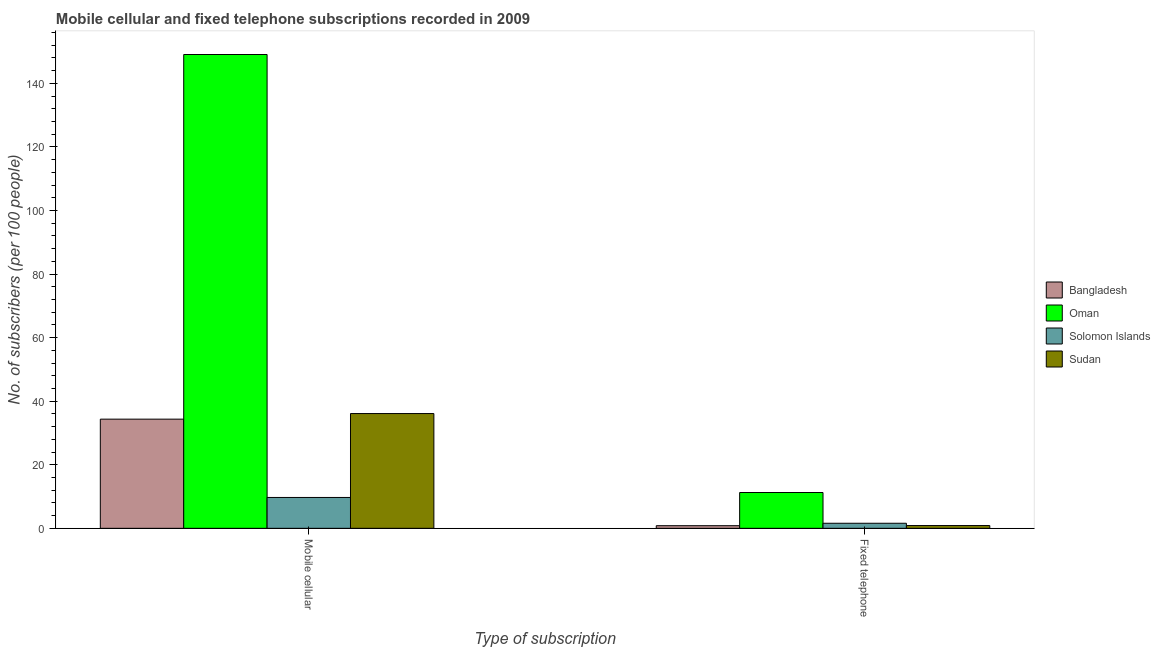Are the number of bars on each tick of the X-axis equal?
Offer a very short reply. Yes. How many bars are there on the 2nd tick from the left?
Give a very brief answer. 4. How many bars are there on the 1st tick from the right?
Offer a very short reply. 4. What is the label of the 1st group of bars from the left?
Provide a succinct answer. Mobile cellular. What is the number of fixed telephone subscribers in Solomon Islands?
Your answer should be very brief. 1.59. Across all countries, what is the maximum number of mobile cellular subscribers?
Keep it short and to the point. 149.09. Across all countries, what is the minimum number of fixed telephone subscribers?
Offer a terse response. 0.83. In which country was the number of mobile cellular subscribers maximum?
Ensure brevity in your answer.  Oman. What is the total number of fixed telephone subscribers in the graph?
Keep it short and to the point. 14.56. What is the difference between the number of fixed telephone subscribers in Oman and that in Solomon Islands?
Your answer should be very brief. 9.68. What is the difference between the number of fixed telephone subscribers in Oman and the number of mobile cellular subscribers in Bangladesh?
Your response must be concise. -23.08. What is the average number of mobile cellular subscribers per country?
Ensure brevity in your answer.  57.32. What is the difference between the number of fixed telephone subscribers and number of mobile cellular subscribers in Sudan?
Make the answer very short. -35.24. In how many countries, is the number of fixed telephone subscribers greater than 136 ?
Your answer should be compact. 0. What is the ratio of the number of mobile cellular subscribers in Sudan to that in Solomon Islands?
Provide a succinct answer. 3.72. Is the number of mobile cellular subscribers in Solomon Islands less than that in Oman?
Provide a short and direct response. Yes. In how many countries, is the number of mobile cellular subscribers greater than the average number of mobile cellular subscribers taken over all countries?
Your answer should be very brief. 1. What does the 4th bar from the left in Fixed telephone represents?
Your answer should be very brief. Sudan. What does the 1st bar from the right in Fixed telephone represents?
Your answer should be very brief. Sudan. Are all the bars in the graph horizontal?
Give a very brief answer. No. What is the difference between two consecutive major ticks on the Y-axis?
Give a very brief answer. 20. Does the graph contain any zero values?
Make the answer very short. No. Does the graph contain grids?
Offer a terse response. No. What is the title of the graph?
Offer a terse response. Mobile cellular and fixed telephone subscriptions recorded in 2009. Does "Mali" appear as one of the legend labels in the graph?
Your answer should be compact. No. What is the label or title of the X-axis?
Offer a very short reply. Type of subscription. What is the label or title of the Y-axis?
Your response must be concise. No. of subscribers (per 100 people). What is the No. of subscribers (per 100 people) of Bangladesh in Mobile cellular?
Provide a short and direct response. 34.35. What is the No. of subscribers (per 100 people) of Oman in Mobile cellular?
Provide a short and direct response. 149.09. What is the No. of subscribers (per 100 people) in Solomon Islands in Mobile cellular?
Give a very brief answer. 9.71. What is the No. of subscribers (per 100 people) of Sudan in Mobile cellular?
Provide a succinct answer. 36.11. What is the No. of subscribers (per 100 people) in Bangladesh in Fixed telephone?
Your answer should be very brief. 0.83. What is the No. of subscribers (per 100 people) of Oman in Fixed telephone?
Give a very brief answer. 11.27. What is the No. of subscribers (per 100 people) in Solomon Islands in Fixed telephone?
Your answer should be very brief. 1.59. What is the No. of subscribers (per 100 people) in Sudan in Fixed telephone?
Give a very brief answer. 0.87. Across all Type of subscription, what is the maximum No. of subscribers (per 100 people) of Bangladesh?
Your response must be concise. 34.35. Across all Type of subscription, what is the maximum No. of subscribers (per 100 people) in Oman?
Give a very brief answer. 149.09. Across all Type of subscription, what is the maximum No. of subscribers (per 100 people) in Solomon Islands?
Keep it short and to the point. 9.71. Across all Type of subscription, what is the maximum No. of subscribers (per 100 people) of Sudan?
Offer a very short reply. 36.11. Across all Type of subscription, what is the minimum No. of subscribers (per 100 people) in Bangladesh?
Keep it short and to the point. 0.83. Across all Type of subscription, what is the minimum No. of subscribers (per 100 people) in Oman?
Your answer should be very brief. 11.27. Across all Type of subscription, what is the minimum No. of subscribers (per 100 people) of Solomon Islands?
Your response must be concise. 1.59. Across all Type of subscription, what is the minimum No. of subscribers (per 100 people) in Sudan?
Your answer should be compact. 0.87. What is the total No. of subscribers (per 100 people) in Bangladesh in the graph?
Keep it short and to the point. 35.18. What is the total No. of subscribers (per 100 people) of Oman in the graph?
Keep it short and to the point. 160.36. What is the total No. of subscribers (per 100 people) in Solomon Islands in the graph?
Your answer should be compact. 11.3. What is the total No. of subscribers (per 100 people) of Sudan in the graph?
Your response must be concise. 36.98. What is the difference between the No. of subscribers (per 100 people) in Bangladesh in Mobile cellular and that in Fixed telephone?
Your response must be concise. 33.53. What is the difference between the No. of subscribers (per 100 people) in Oman in Mobile cellular and that in Fixed telephone?
Your answer should be very brief. 137.82. What is the difference between the No. of subscribers (per 100 people) in Solomon Islands in Mobile cellular and that in Fixed telephone?
Your answer should be very brief. 8.12. What is the difference between the No. of subscribers (per 100 people) of Sudan in Mobile cellular and that in Fixed telephone?
Keep it short and to the point. 35.24. What is the difference between the No. of subscribers (per 100 people) in Bangladesh in Mobile cellular and the No. of subscribers (per 100 people) in Oman in Fixed telephone?
Your answer should be compact. 23.08. What is the difference between the No. of subscribers (per 100 people) of Bangladesh in Mobile cellular and the No. of subscribers (per 100 people) of Solomon Islands in Fixed telephone?
Your response must be concise. 32.76. What is the difference between the No. of subscribers (per 100 people) in Bangladesh in Mobile cellular and the No. of subscribers (per 100 people) in Sudan in Fixed telephone?
Make the answer very short. 33.48. What is the difference between the No. of subscribers (per 100 people) of Oman in Mobile cellular and the No. of subscribers (per 100 people) of Solomon Islands in Fixed telephone?
Offer a terse response. 147.5. What is the difference between the No. of subscribers (per 100 people) in Oman in Mobile cellular and the No. of subscribers (per 100 people) in Sudan in Fixed telephone?
Your answer should be compact. 148.22. What is the difference between the No. of subscribers (per 100 people) in Solomon Islands in Mobile cellular and the No. of subscribers (per 100 people) in Sudan in Fixed telephone?
Provide a short and direct response. 8.84. What is the average No. of subscribers (per 100 people) of Bangladesh per Type of subscription?
Provide a short and direct response. 17.59. What is the average No. of subscribers (per 100 people) in Oman per Type of subscription?
Make the answer very short. 80.18. What is the average No. of subscribers (per 100 people) of Solomon Islands per Type of subscription?
Offer a very short reply. 5.65. What is the average No. of subscribers (per 100 people) of Sudan per Type of subscription?
Make the answer very short. 18.49. What is the difference between the No. of subscribers (per 100 people) of Bangladesh and No. of subscribers (per 100 people) of Oman in Mobile cellular?
Make the answer very short. -114.74. What is the difference between the No. of subscribers (per 100 people) in Bangladesh and No. of subscribers (per 100 people) in Solomon Islands in Mobile cellular?
Ensure brevity in your answer.  24.64. What is the difference between the No. of subscribers (per 100 people) in Bangladesh and No. of subscribers (per 100 people) in Sudan in Mobile cellular?
Keep it short and to the point. -1.76. What is the difference between the No. of subscribers (per 100 people) in Oman and No. of subscribers (per 100 people) in Solomon Islands in Mobile cellular?
Provide a short and direct response. 139.38. What is the difference between the No. of subscribers (per 100 people) in Oman and No. of subscribers (per 100 people) in Sudan in Mobile cellular?
Provide a succinct answer. 112.98. What is the difference between the No. of subscribers (per 100 people) in Solomon Islands and No. of subscribers (per 100 people) in Sudan in Mobile cellular?
Provide a short and direct response. -26.4. What is the difference between the No. of subscribers (per 100 people) of Bangladesh and No. of subscribers (per 100 people) of Oman in Fixed telephone?
Provide a succinct answer. -10.44. What is the difference between the No. of subscribers (per 100 people) of Bangladesh and No. of subscribers (per 100 people) of Solomon Islands in Fixed telephone?
Give a very brief answer. -0.77. What is the difference between the No. of subscribers (per 100 people) in Bangladesh and No. of subscribers (per 100 people) in Sudan in Fixed telephone?
Ensure brevity in your answer.  -0.05. What is the difference between the No. of subscribers (per 100 people) in Oman and No. of subscribers (per 100 people) in Solomon Islands in Fixed telephone?
Offer a very short reply. 9.68. What is the difference between the No. of subscribers (per 100 people) in Oman and No. of subscribers (per 100 people) in Sudan in Fixed telephone?
Keep it short and to the point. 10.4. What is the difference between the No. of subscribers (per 100 people) of Solomon Islands and No. of subscribers (per 100 people) of Sudan in Fixed telephone?
Your answer should be very brief. 0.72. What is the ratio of the No. of subscribers (per 100 people) of Bangladesh in Mobile cellular to that in Fixed telephone?
Provide a succinct answer. 41.59. What is the ratio of the No. of subscribers (per 100 people) of Oman in Mobile cellular to that in Fixed telephone?
Make the answer very short. 13.23. What is the ratio of the No. of subscribers (per 100 people) in Solomon Islands in Mobile cellular to that in Fixed telephone?
Offer a terse response. 6.1. What is the ratio of the No. of subscribers (per 100 people) in Sudan in Mobile cellular to that in Fixed telephone?
Ensure brevity in your answer.  41.41. What is the difference between the highest and the second highest No. of subscribers (per 100 people) of Bangladesh?
Provide a short and direct response. 33.53. What is the difference between the highest and the second highest No. of subscribers (per 100 people) in Oman?
Offer a very short reply. 137.82. What is the difference between the highest and the second highest No. of subscribers (per 100 people) of Solomon Islands?
Your answer should be compact. 8.12. What is the difference between the highest and the second highest No. of subscribers (per 100 people) in Sudan?
Your response must be concise. 35.24. What is the difference between the highest and the lowest No. of subscribers (per 100 people) of Bangladesh?
Make the answer very short. 33.53. What is the difference between the highest and the lowest No. of subscribers (per 100 people) in Oman?
Your answer should be compact. 137.82. What is the difference between the highest and the lowest No. of subscribers (per 100 people) of Solomon Islands?
Offer a very short reply. 8.12. What is the difference between the highest and the lowest No. of subscribers (per 100 people) of Sudan?
Offer a very short reply. 35.24. 